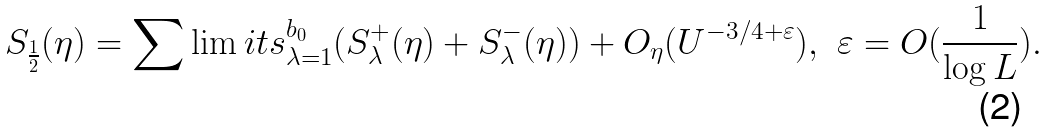Convert formula to latex. <formula><loc_0><loc_0><loc_500><loc_500>S _ { \frac { 1 } { 2 } } ( \eta ) = \sum \lim i t s _ { \lambda = 1 } ^ { b _ { 0 } } ( S _ { \lambda } ^ { + } ( \eta ) + S _ { \lambda } ^ { - } ( \eta ) ) + O _ { \eta } ( U ^ { - 3 / 4 + \varepsilon } ) , \ \varepsilon = O ( \frac { 1 } { \log L } ) .</formula> 